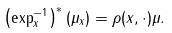Convert formula to latex. <formula><loc_0><loc_0><loc_500><loc_500>\left ( \exp _ { x } ^ { - 1 } \right ) ^ { * } ( \mu _ { x } ) = \rho ( x , \cdot ) \mu .</formula> 